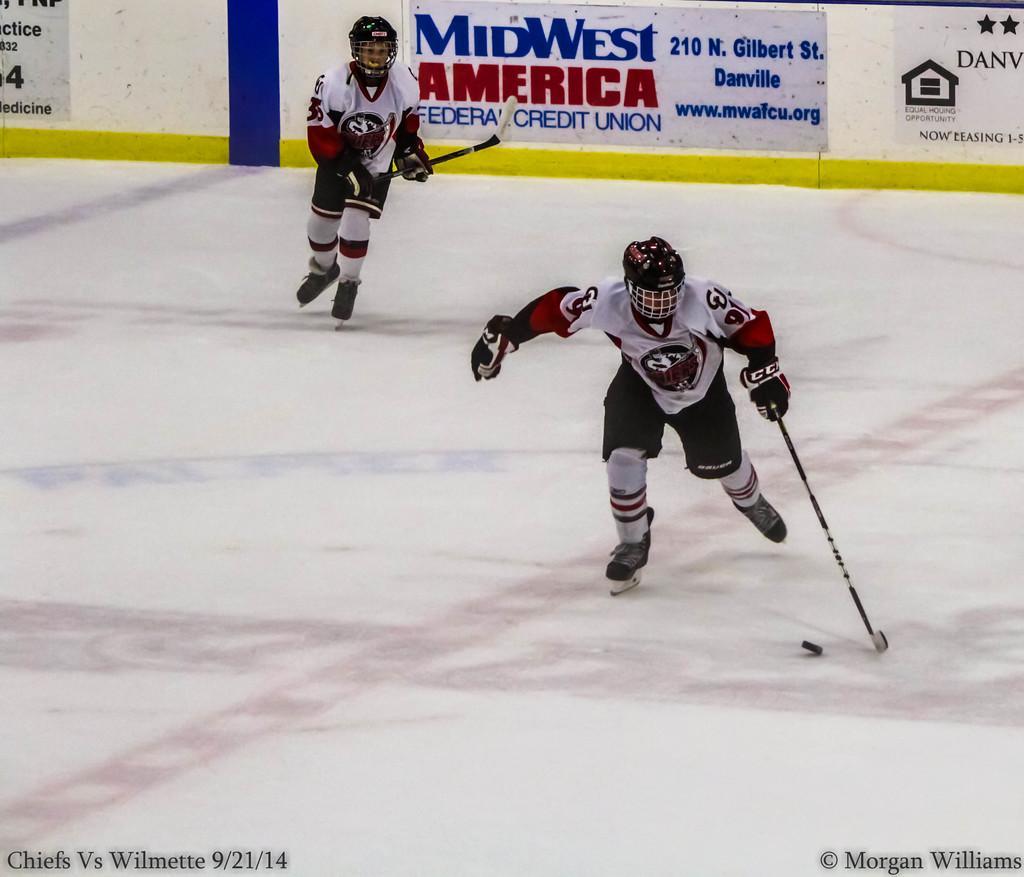How would you summarize this image in a sentence or two? In this image we can see two persons wearing similar dress, helmets, shows playing hockey holding hockey sticks in their hands and at the background of the image there is white color sheet. 